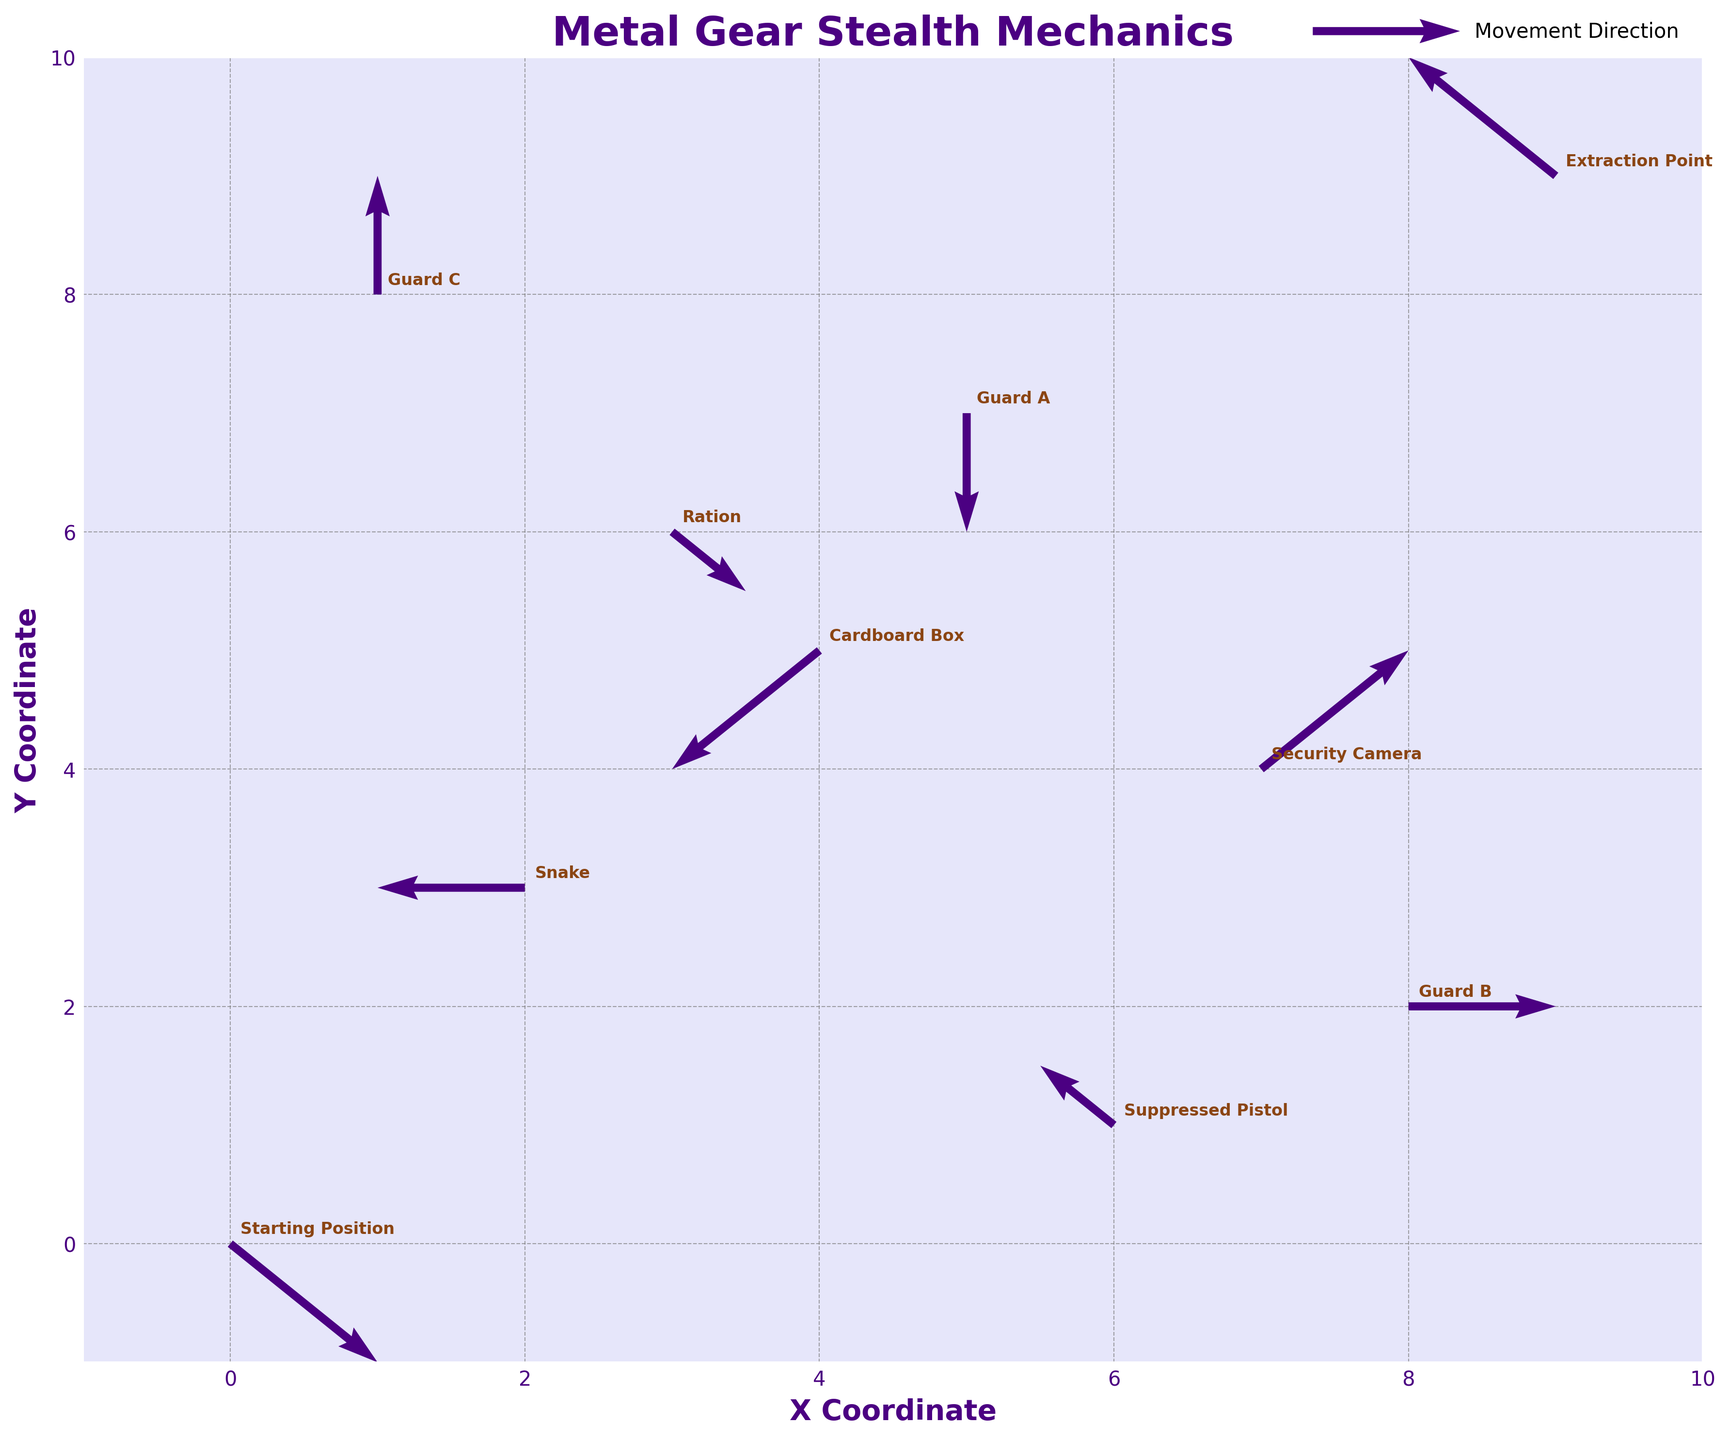what is the title of the plot? The title of the plot is displayed prominently at the top and is meant to provide a quick understanding of the visual's purpose. Here, it reads "Metal Gear Stealth Mechanics".
Answer: Metal Gear Stealth Mechanics how many unique labels are there in the plot? By viewing the figure and counting the distinct text annotations, we identify the unique labels corresponding to each object's name. There are 10 unique labels.
Answer: 10 which guard is positioned closest to Snake? To determine this, note the coordinates of Snake and compare the distances to all guards. Snake is at (2, 3). Guard A is at (5, 7), Guard B is at (8, 2), and Guard C is at (1, 8). The closest distance is seen via visual examination, revealing that Guard C is closest.
Answer: Guard C what is the direction of Guard A's movement? The direction is indicated by the arrow starting from Guard A's position (5, 7) pointing in the direction indicated by the vector (0, -1). This signifies a downward movement on the plot.
Answer: downward which objects are involved in intercepting movements? Intercepting movements would involve objects whose arrows cross paths. By tracing the arrows, we see that "Security Camera" and "Suppressed Pistol" arrows intersect.
Answer: Security Camera and Suppressed Pistol what is the positional direction of the "Cardboard Box" relative to "Ration"? The Cardboard Box is located at (4, 5) and the Ration is at (3, 6). To find the direction, note the difference: (4-3, 5-6) = (1, -1), indicating a southwest direction.
Answer: southwest which label has the longest movement vector? Length of vectors can be estimated visually by the size of the arrows. "Security Camera" and "Guard C" seem longer. Accuracy can be assured by considering vector magnitudes calculated by sqrt(u²+v²). Both have magnitude of sqrt(2).
Answer: Security Camera and Guard C what color are the movement vectors? Movement vectors in the plot are colored for clarity. By observing the lines that represent movements (arrows), it's notable they are colored deep purple.
Answer: deep purple how does the player's strategy to avoid Guard A differ from Guard C? Examining Snake's movement vector (-1, 0) to determine evasion tactics. Guard A (0, -1) generally overlaps paths except directions, while Guard C's (0, 1) strategy involves vertical evasion. Snake avoids horizontally for Guard A and vertically for Guard C.
Answer: horizontally vs vertically 